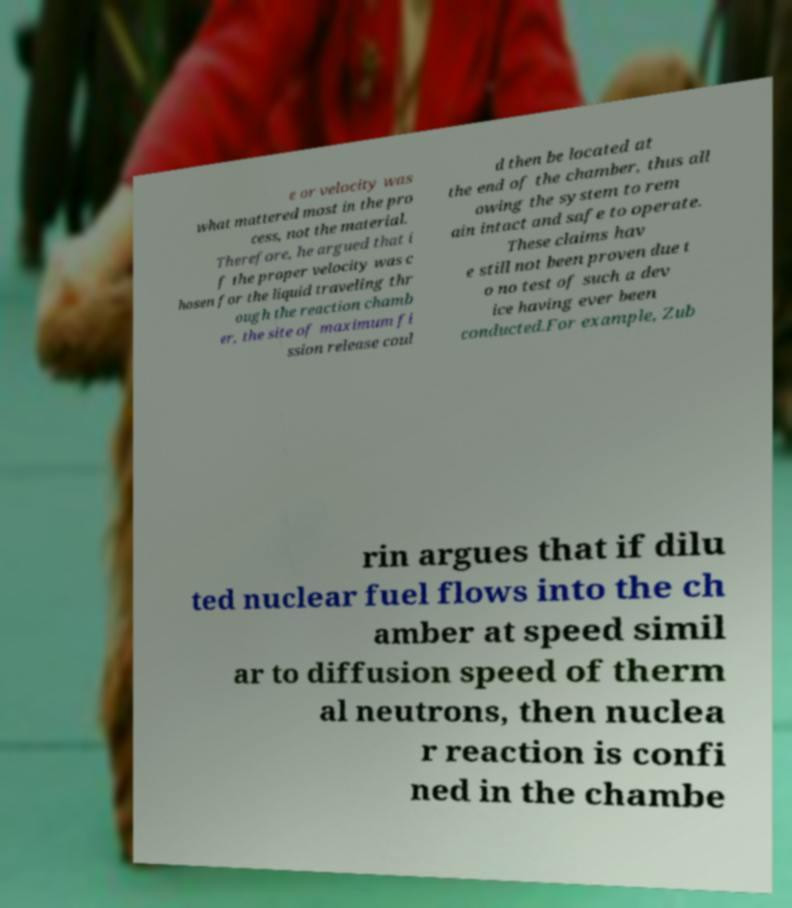Can you accurately transcribe the text from the provided image for me? e or velocity was what mattered most in the pro cess, not the material. Therefore, he argued that i f the proper velocity was c hosen for the liquid traveling thr ough the reaction chamb er, the site of maximum fi ssion release coul d then be located at the end of the chamber, thus all owing the system to rem ain intact and safe to operate. These claims hav e still not been proven due t o no test of such a dev ice having ever been conducted.For example, Zub rin argues that if dilu ted nuclear fuel flows into the ch amber at speed simil ar to diffusion speed of therm al neutrons, then nuclea r reaction is confi ned in the chambe 